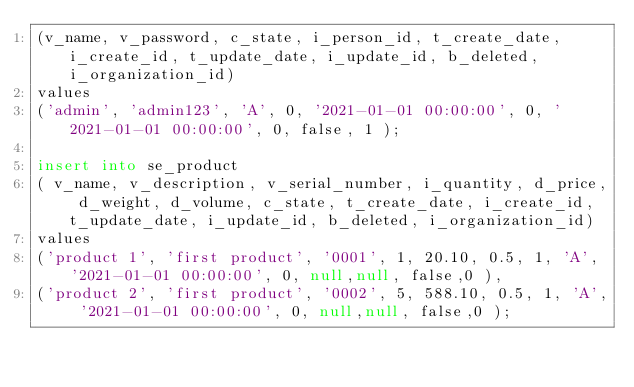<code> <loc_0><loc_0><loc_500><loc_500><_SQL_>(v_name, v_password, c_state, i_person_id, t_create_date, i_create_id, t_update_date, i_update_id, b_deleted, i_organization_id)
values
('admin', 'admin123', 'A', 0, '2021-01-01 00:00:00', 0, '2021-01-01 00:00:00', 0, false, 1 );

insert into se_product
( v_name, v_description, v_serial_number, i_quantity, d_price, d_weight, d_volume, c_state, t_create_date, i_create_id, t_update_date, i_update_id, b_deleted, i_organization_id)
values
('product 1', 'first product', '0001', 1, 20.10, 0.5, 1, 'A', '2021-01-01 00:00:00', 0, null,null, false,0 ),
('product 2', 'first product', '0002', 5, 588.10, 0.5, 1, 'A', '2021-01-01 00:00:00', 0, null,null, false,0 );</code> 